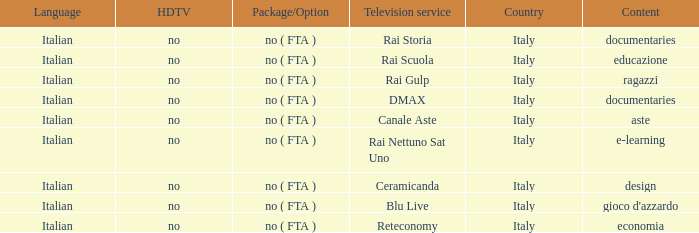What is the Language when the Reteconomy is the television service? Italian. 